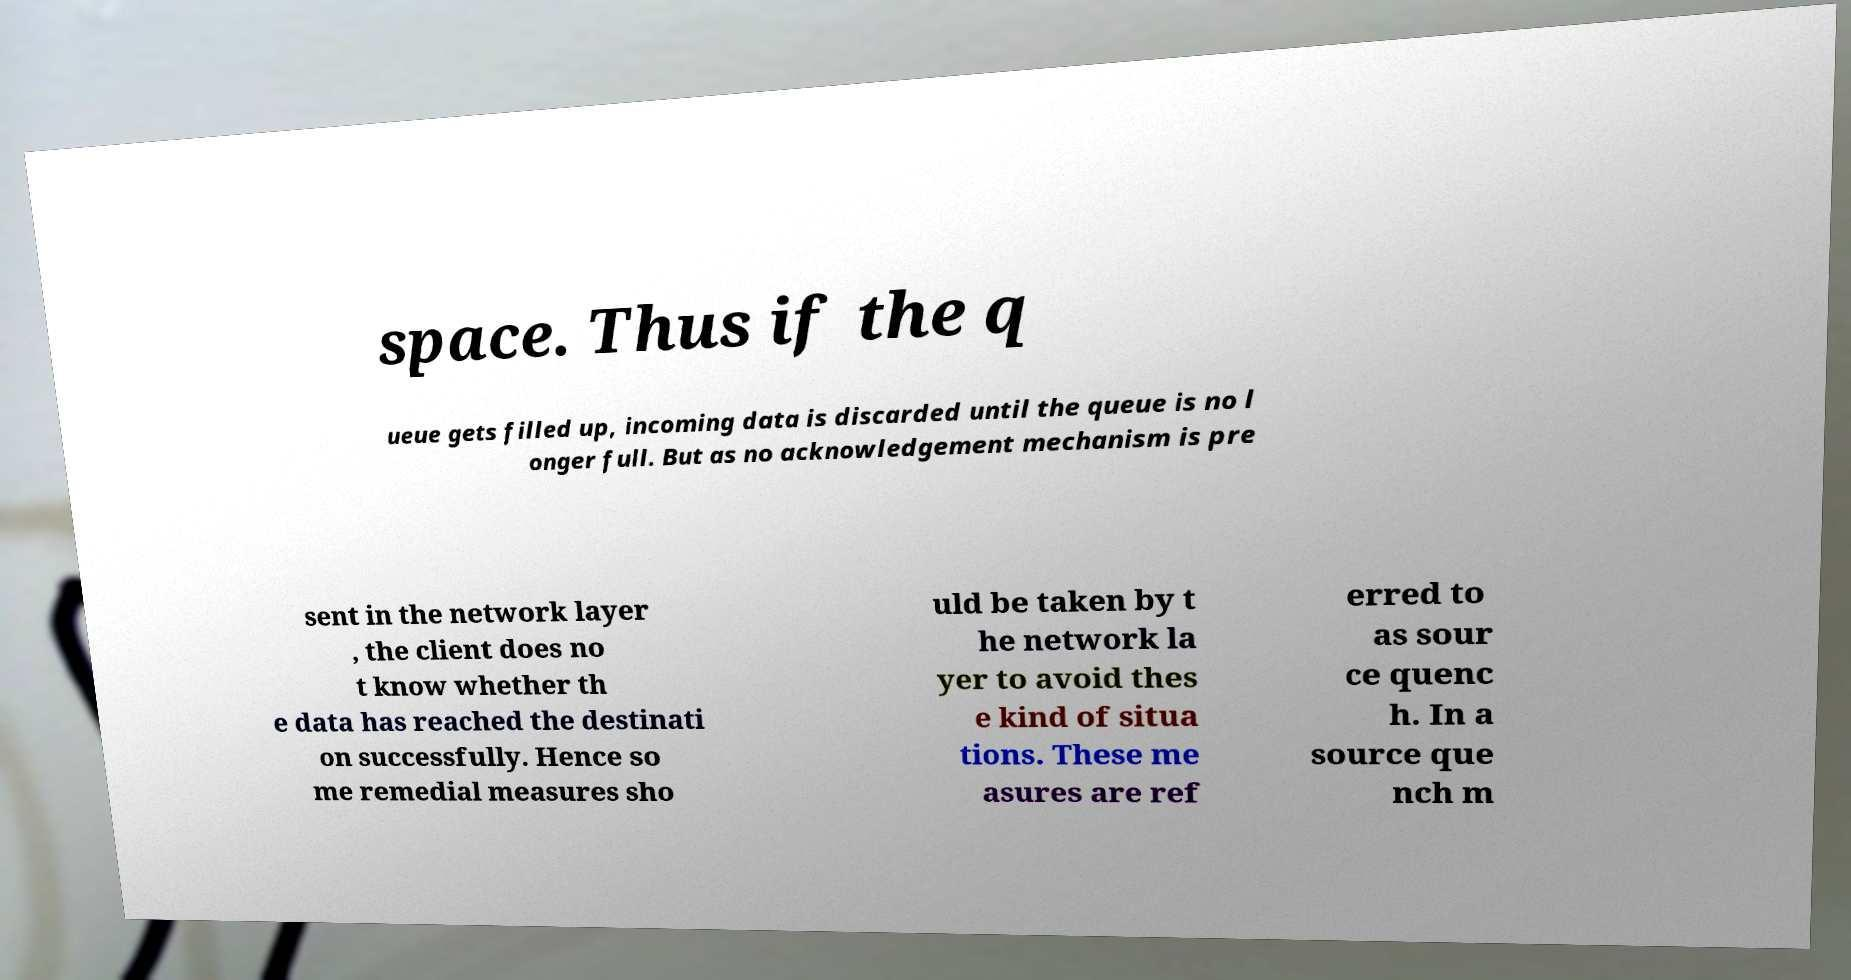Please read and relay the text visible in this image. What does it say? space. Thus if the q ueue gets filled up, incoming data is discarded until the queue is no l onger full. But as no acknowledgement mechanism is pre sent in the network layer , the client does no t know whether th e data has reached the destinati on successfully. Hence so me remedial measures sho uld be taken by t he network la yer to avoid thes e kind of situa tions. These me asures are ref erred to as sour ce quenc h. In a source que nch m 